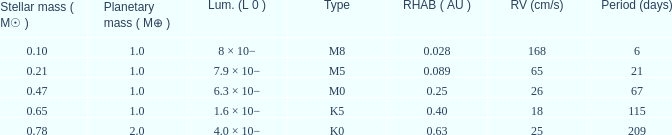What is the highest planetary mass having an RV (cm/s) of 65 and a Period (days) less than 21? None. 